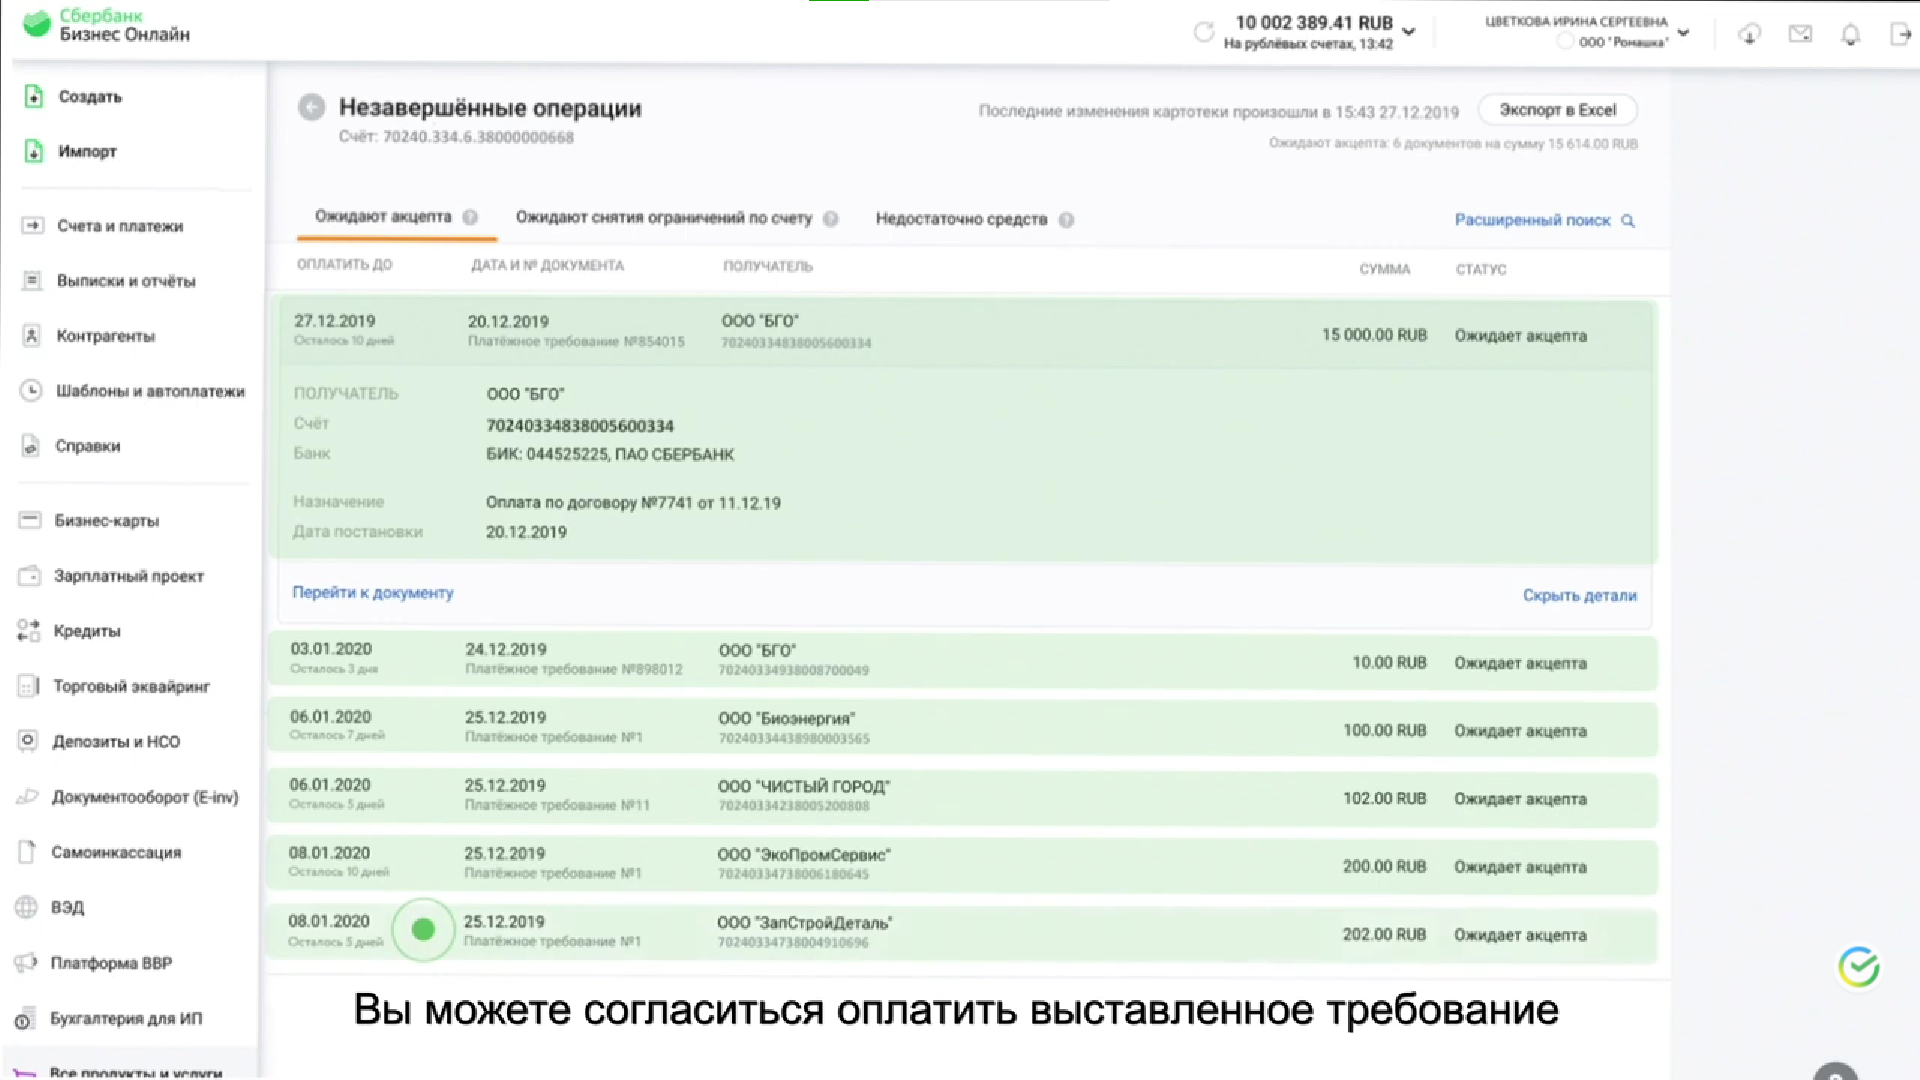Какой остаток на рублевых счетах Остаток на рублевых счетах составляет 10 002 389.41 рублей. Перечисли получателей незавершенных операций Получатели незавершенных операций:

1. ООО "БГО"
2. ООО "Биозенергия"
3. ООО "Чистый Город"
4. ООО "ЭкоПромСервис"
5. ООО "ЗапСтройДеталь" 